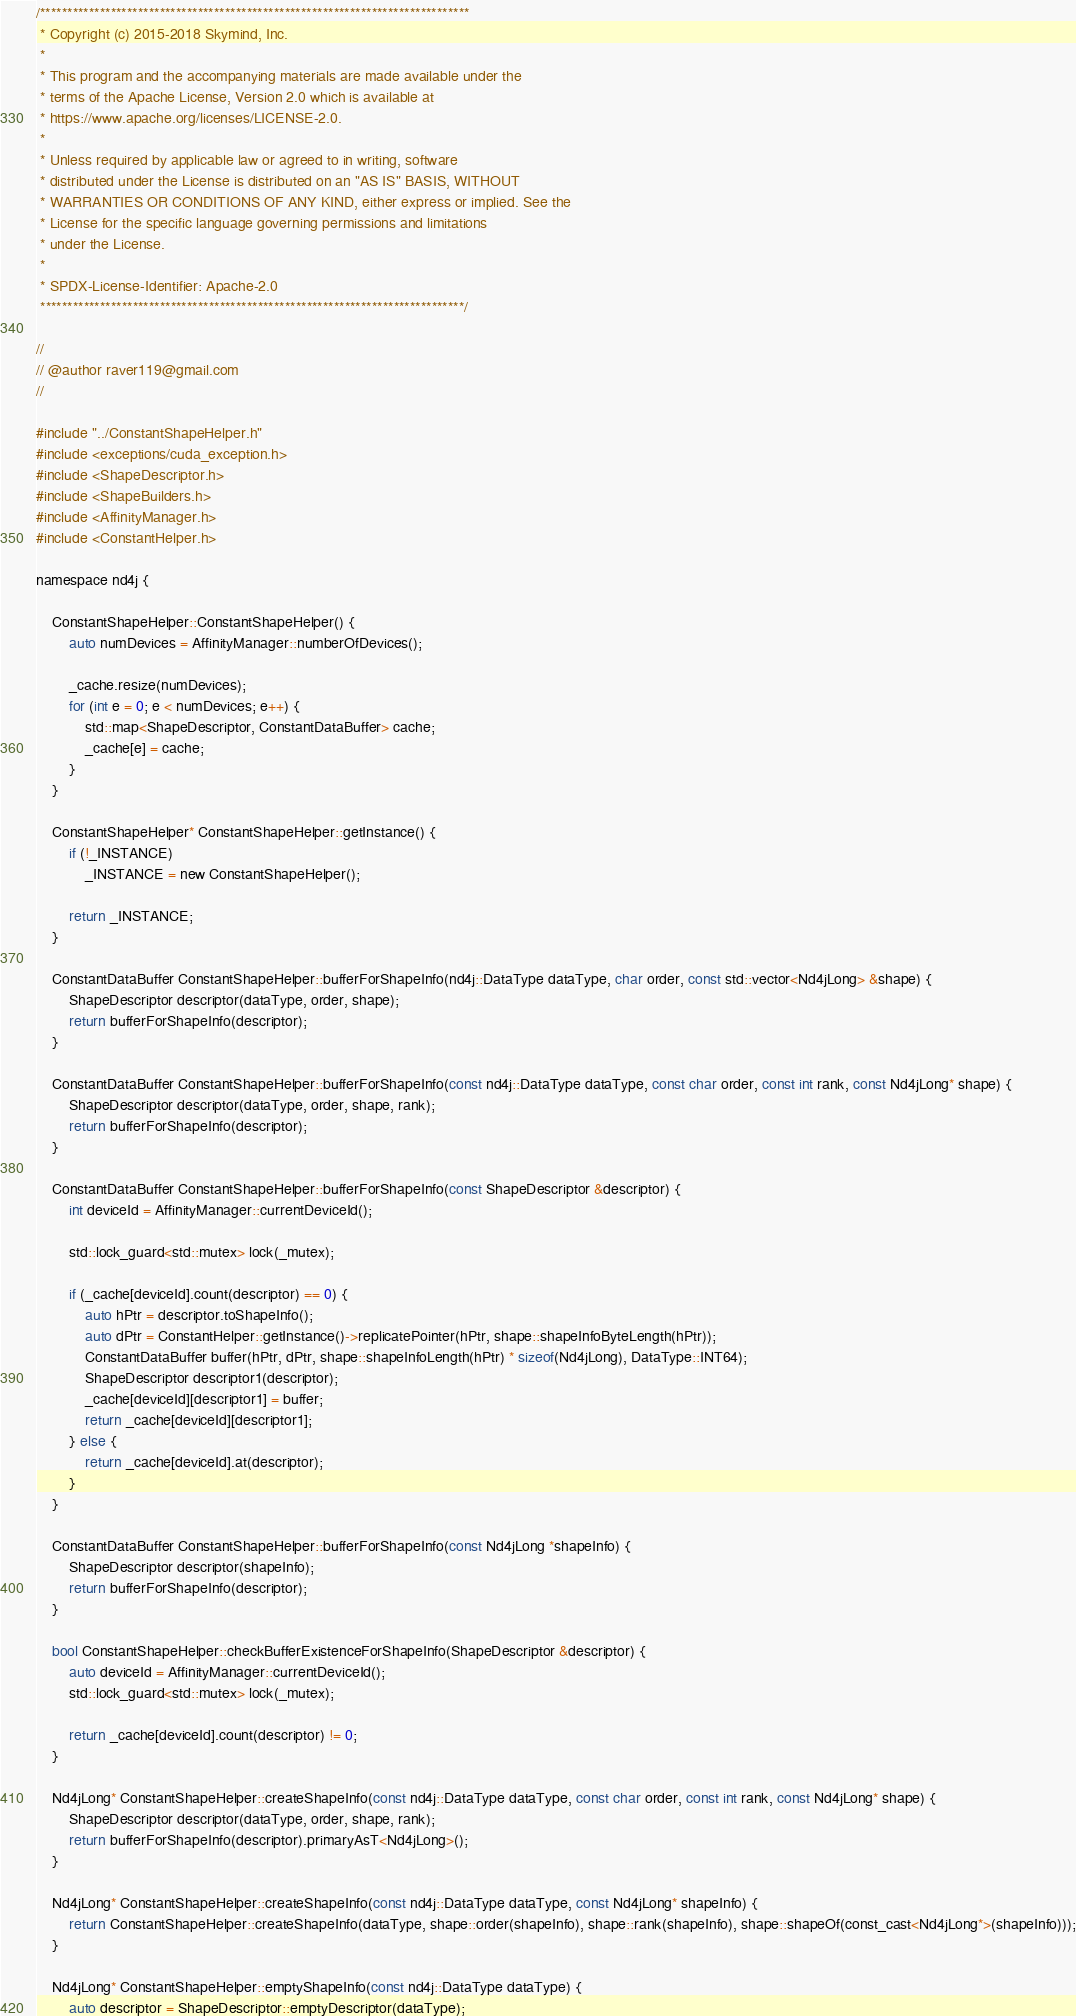Convert code to text. <code><loc_0><loc_0><loc_500><loc_500><_Cuda_>/*******************************************************************************
 * Copyright (c) 2015-2018 Skymind, Inc.
 *
 * This program and the accompanying materials are made available under the
 * terms of the Apache License, Version 2.0 which is available at
 * https://www.apache.org/licenses/LICENSE-2.0.
 *
 * Unless required by applicable law or agreed to in writing, software
 * distributed under the License is distributed on an "AS IS" BASIS, WITHOUT
 * WARRANTIES OR CONDITIONS OF ANY KIND, either express or implied. See the
 * License for the specific language governing permissions and limitations
 * under the License.
 *
 * SPDX-License-Identifier: Apache-2.0
 ******************************************************************************/

//
// @author raver119@gmail.com
//

#include "../ConstantShapeHelper.h"
#include <exceptions/cuda_exception.h>
#include <ShapeDescriptor.h>
#include <ShapeBuilders.h>
#include <AffinityManager.h>
#include <ConstantHelper.h>

namespace nd4j {

    ConstantShapeHelper::ConstantShapeHelper() {
        auto numDevices = AffinityManager::numberOfDevices();

        _cache.resize(numDevices);
        for (int e = 0; e < numDevices; e++) {
            std::map<ShapeDescriptor, ConstantDataBuffer> cache;
            _cache[e] = cache;
        }
    }

    ConstantShapeHelper* ConstantShapeHelper::getInstance() {
        if (!_INSTANCE)
            _INSTANCE = new ConstantShapeHelper();

        return _INSTANCE;
    }

    ConstantDataBuffer ConstantShapeHelper::bufferForShapeInfo(nd4j::DataType dataType, char order, const std::vector<Nd4jLong> &shape) {
        ShapeDescriptor descriptor(dataType, order, shape);
        return bufferForShapeInfo(descriptor);
    }

    ConstantDataBuffer ConstantShapeHelper::bufferForShapeInfo(const nd4j::DataType dataType, const char order, const int rank, const Nd4jLong* shape) {
        ShapeDescriptor descriptor(dataType, order, shape, rank);
        return bufferForShapeInfo(descriptor);
    }

    ConstantDataBuffer ConstantShapeHelper::bufferForShapeInfo(const ShapeDescriptor &descriptor) {
        int deviceId = AffinityManager::currentDeviceId();

        std::lock_guard<std::mutex> lock(_mutex);

        if (_cache[deviceId].count(descriptor) == 0) {
            auto hPtr = descriptor.toShapeInfo();
            auto dPtr = ConstantHelper::getInstance()->replicatePointer(hPtr, shape::shapeInfoByteLength(hPtr));
            ConstantDataBuffer buffer(hPtr, dPtr, shape::shapeInfoLength(hPtr) * sizeof(Nd4jLong), DataType::INT64);
            ShapeDescriptor descriptor1(descriptor);
            _cache[deviceId][descriptor1] = buffer;
            return _cache[deviceId][descriptor1];
        } else {
            return _cache[deviceId].at(descriptor);
        }
    }

    ConstantDataBuffer ConstantShapeHelper::bufferForShapeInfo(const Nd4jLong *shapeInfo) {
        ShapeDescriptor descriptor(shapeInfo);
        return bufferForShapeInfo(descriptor);
    }

    bool ConstantShapeHelper::checkBufferExistenceForShapeInfo(ShapeDescriptor &descriptor) {
        auto deviceId = AffinityManager::currentDeviceId();
        std::lock_guard<std::mutex> lock(_mutex);

        return _cache[deviceId].count(descriptor) != 0;
    }

    Nd4jLong* ConstantShapeHelper::createShapeInfo(const nd4j::DataType dataType, const char order, const int rank, const Nd4jLong* shape) {
        ShapeDescriptor descriptor(dataType, order, shape, rank);
        return bufferForShapeInfo(descriptor).primaryAsT<Nd4jLong>();
    }

    Nd4jLong* ConstantShapeHelper::createShapeInfo(const nd4j::DataType dataType, const Nd4jLong* shapeInfo) {
        return ConstantShapeHelper::createShapeInfo(dataType, shape::order(shapeInfo), shape::rank(shapeInfo), shape::shapeOf(const_cast<Nd4jLong*>(shapeInfo)));
    }

    Nd4jLong* ConstantShapeHelper::emptyShapeInfo(const nd4j::DataType dataType) {
        auto descriptor = ShapeDescriptor::emptyDescriptor(dataType);</code> 